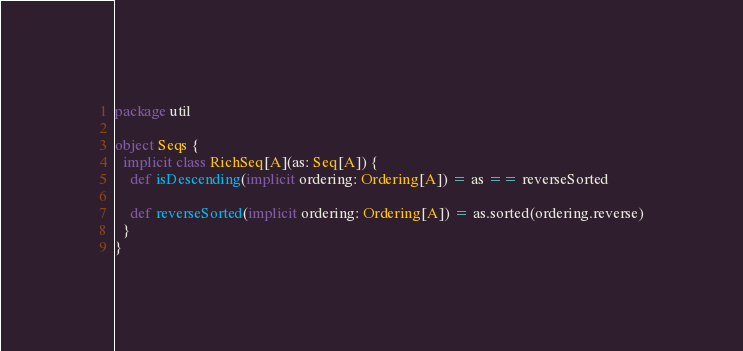Convert code to text. <code><loc_0><loc_0><loc_500><loc_500><_Scala_>package util

object Seqs {
  implicit class RichSeq[A](as: Seq[A]) {
    def isDescending(implicit ordering: Ordering[A]) = as == reverseSorted

    def reverseSorted(implicit ordering: Ordering[A]) = as.sorted(ordering.reverse)
  }
}
</code> 